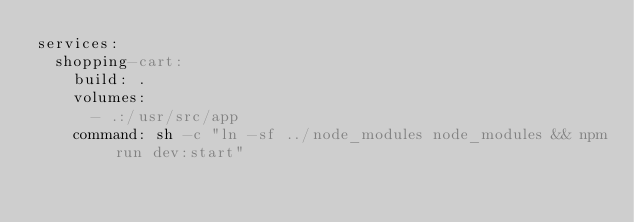Convert code to text. <code><loc_0><loc_0><loc_500><loc_500><_YAML_>services:
  shopping-cart:
    build: .
    volumes:
      - .:/usr/src/app
    command: sh -c "ln -sf ../node_modules node_modules && npm run dev:start"</code> 